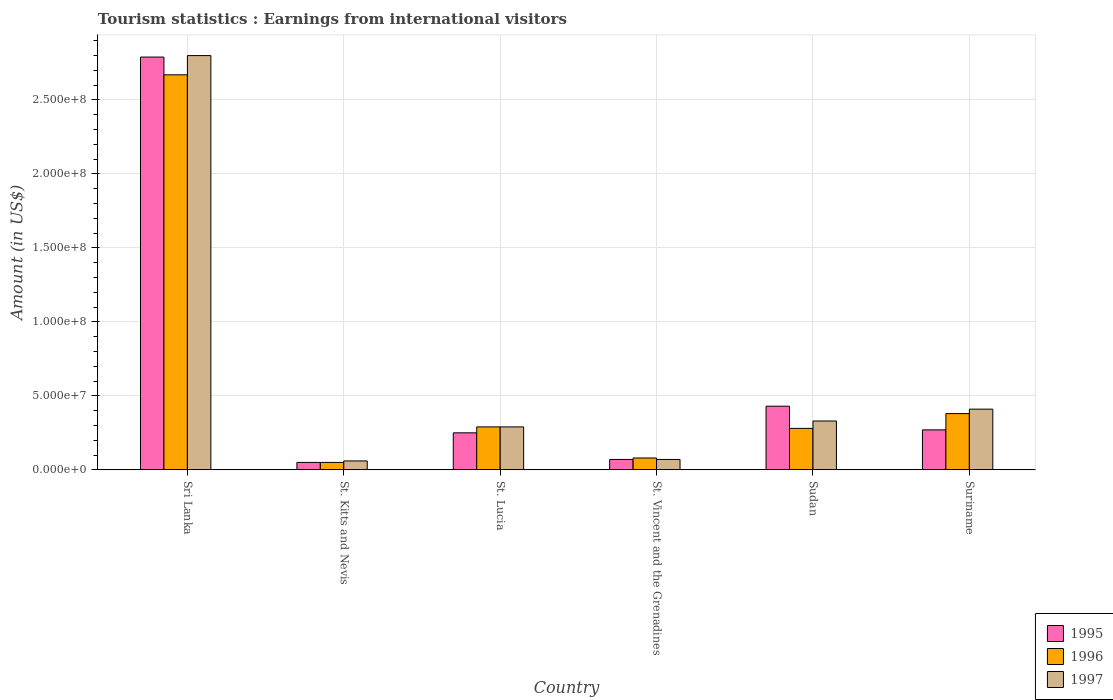How many groups of bars are there?
Make the answer very short. 6. How many bars are there on the 5th tick from the left?
Your answer should be compact. 3. How many bars are there on the 6th tick from the right?
Offer a terse response. 3. What is the label of the 3rd group of bars from the left?
Ensure brevity in your answer.  St. Lucia. What is the earnings from international visitors in 1997 in Sri Lanka?
Your answer should be very brief. 2.80e+08. Across all countries, what is the maximum earnings from international visitors in 1996?
Your response must be concise. 2.67e+08. Across all countries, what is the minimum earnings from international visitors in 1997?
Provide a succinct answer. 6.00e+06. In which country was the earnings from international visitors in 1997 maximum?
Offer a very short reply. Sri Lanka. In which country was the earnings from international visitors in 1996 minimum?
Make the answer very short. St. Kitts and Nevis. What is the total earnings from international visitors in 1996 in the graph?
Your answer should be very brief. 3.75e+08. What is the difference between the earnings from international visitors in 1996 in Sri Lanka and that in St. Kitts and Nevis?
Provide a succinct answer. 2.62e+08. What is the difference between the earnings from international visitors in 1996 in Sudan and the earnings from international visitors in 1995 in St. Kitts and Nevis?
Your answer should be compact. 2.30e+07. What is the average earnings from international visitors in 1995 per country?
Offer a very short reply. 6.43e+07. What is the ratio of the earnings from international visitors in 1997 in Sri Lanka to that in Sudan?
Your answer should be very brief. 8.48. Is the earnings from international visitors in 1995 in Sri Lanka less than that in St. Kitts and Nevis?
Offer a terse response. No. What is the difference between the highest and the second highest earnings from international visitors in 1997?
Make the answer very short. 2.47e+08. What is the difference between the highest and the lowest earnings from international visitors in 1997?
Ensure brevity in your answer.  2.74e+08. In how many countries, is the earnings from international visitors in 1997 greater than the average earnings from international visitors in 1997 taken over all countries?
Provide a short and direct response. 1. Is the sum of the earnings from international visitors in 1996 in St. Vincent and the Grenadines and Suriname greater than the maximum earnings from international visitors in 1995 across all countries?
Your answer should be compact. No. What does the 3rd bar from the left in St. Lucia represents?
Offer a terse response. 1997. Is it the case that in every country, the sum of the earnings from international visitors in 1997 and earnings from international visitors in 1996 is greater than the earnings from international visitors in 1995?
Your response must be concise. Yes. How many countries are there in the graph?
Make the answer very short. 6. Are the values on the major ticks of Y-axis written in scientific E-notation?
Keep it short and to the point. Yes. Does the graph contain grids?
Give a very brief answer. Yes. Where does the legend appear in the graph?
Provide a succinct answer. Bottom right. How are the legend labels stacked?
Your answer should be very brief. Vertical. What is the title of the graph?
Provide a short and direct response. Tourism statistics : Earnings from international visitors. Does "1963" appear as one of the legend labels in the graph?
Provide a succinct answer. No. What is the Amount (in US$) of 1995 in Sri Lanka?
Offer a very short reply. 2.79e+08. What is the Amount (in US$) in 1996 in Sri Lanka?
Ensure brevity in your answer.  2.67e+08. What is the Amount (in US$) of 1997 in Sri Lanka?
Your answer should be very brief. 2.80e+08. What is the Amount (in US$) in 1995 in St. Kitts and Nevis?
Keep it short and to the point. 5.00e+06. What is the Amount (in US$) in 1996 in St. Kitts and Nevis?
Ensure brevity in your answer.  5.00e+06. What is the Amount (in US$) in 1995 in St. Lucia?
Your answer should be very brief. 2.50e+07. What is the Amount (in US$) of 1996 in St. Lucia?
Give a very brief answer. 2.90e+07. What is the Amount (in US$) in 1997 in St. Lucia?
Offer a very short reply. 2.90e+07. What is the Amount (in US$) in 1995 in Sudan?
Your answer should be compact. 4.30e+07. What is the Amount (in US$) in 1996 in Sudan?
Your answer should be very brief. 2.80e+07. What is the Amount (in US$) of 1997 in Sudan?
Make the answer very short. 3.30e+07. What is the Amount (in US$) in 1995 in Suriname?
Ensure brevity in your answer.  2.70e+07. What is the Amount (in US$) in 1996 in Suriname?
Provide a short and direct response. 3.80e+07. What is the Amount (in US$) of 1997 in Suriname?
Your response must be concise. 4.10e+07. Across all countries, what is the maximum Amount (in US$) in 1995?
Give a very brief answer. 2.79e+08. Across all countries, what is the maximum Amount (in US$) in 1996?
Keep it short and to the point. 2.67e+08. Across all countries, what is the maximum Amount (in US$) in 1997?
Make the answer very short. 2.80e+08. Across all countries, what is the minimum Amount (in US$) of 1996?
Your answer should be compact. 5.00e+06. Across all countries, what is the minimum Amount (in US$) in 1997?
Your answer should be compact. 6.00e+06. What is the total Amount (in US$) in 1995 in the graph?
Ensure brevity in your answer.  3.86e+08. What is the total Amount (in US$) in 1996 in the graph?
Your response must be concise. 3.75e+08. What is the total Amount (in US$) of 1997 in the graph?
Keep it short and to the point. 3.96e+08. What is the difference between the Amount (in US$) in 1995 in Sri Lanka and that in St. Kitts and Nevis?
Keep it short and to the point. 2.74e+08. What is the difference between the Amount (in US$) of 1996 in Sri Lanka and that in St. Kitts and Nevis?
Offer a terse response. 2.62e+08. What is the difference between the Amount (in US$) in 1997 in Sri Lanka and that in St. Kitts and Nevis?
Your answer should be very brief. 2.74e+08. What is the difference between the Amount (in US$) of 1995 in Sri Lanka and that in St. Lucia?
Provide a succinct answer. 2.54e+08. What is the difference between the Amount (in US$) of 1996 in Sri Lanka and that in St. Lucia?
Ensure brevity in your answer.  2.38e+08. What is the difference between the Amount (in US$) of 1997 in Sri Lanka and that in St. Lucia?
Provide a short and direct response. 2.51e+08. What is the difference between the Amount (in US$) of 1995 in Sri Lanka and that in St. Vincent and the Grenadines?
Your answer should be compact. 2.72e+08. What is the difference between the Amount (in US$) of 1996 in Sri Lanka and that in St. Vincent and the Grenadines?
Your answer should be very brief. 2.59e+08. What is the difference between the Amount (in US$) in 1997 in Sri Lanka and that in St. Vincent and the Grenadines?
Make the answer very short. 2.73e+08. What is the difference between the Amount (in US$) in 1995 in Sri Lanka and that in Sudan?
Provide a short and direct response. 2.36e+08. What is the difference between the Amount (in US$) in 1996 in Sri Lanka and that in Sudan?
Your response must be concise. 2.39e+08. What is the difference between the Amount (in US$) of 1997 in Sri Lanka and that in Sudan?
Your answer should be very brief. 2.47e+08. What is the difference between the Amount (in US$) in 1995 in Sri Lanka and that in Suriname?
Your answer should be very brief. 2.52e+08. What is the difference between the Amount (in US$) in 1996 in Sri Lanka and that in Suriname?
Your response must be concise. 2.29e+08. What is the difference between the Amount (in US$) in 1997 in Sri Lanka and that in Suriname?
Your answer should be compact. 2.39e+08. What is the difference between the Amount (in US$) of 1995 in St. Kitts and Nevis and that in St. Lucia?
Ensure brevity in your answer.  -2.00e+07. What is the difference between the Amount (in US$) of 1996 in St. Kitts and Nevis and that in St. Lucia?
Your answer should be very brief. -2.40e+07. What is the difference between the Amount (in US$) in 1997 in St. Kitts and Nevis and that in St. Lucia?
Offer a very short reply. -2.30e+07. What is the difference between the Amount (in US$) in 1996 in St. Kitts and Nevis and that in St. Vincent and the Grenadines?
Ensure brevity in your answer.  -3.00e+06. What is the difference between the Amount (in US$) of 1995 in St. Kitts and Nevis and that in Sudan?
Keep it short and to the point. -3.80e+07. What is the difference between the Amount (in US$) in 1996 in St. Kitts and Nevis and that in Sudan?
Your answer should be very brief. -2.30e+07. What is the difference between the Amount (in US$) in 1997 in St. Kitts and Nevis and that in Sudan?
Your answer should be very brief. -2.70e+07. What is the difference between the Amount (in US$) of 1995 in St. Kitts and Nevis and that in Suriname?
Ensure brevity in your answer.  -2.20e+07. What is the difference between the Amount (in US$) in 1996 in St. Kitts and Nevis and that in Suriname?
Provide a short and direct response. -3.30e+07. What is the difference between the Amount (in US$) in 1997 in St. Kitts and Nevis and that in Suriname?
Make the answer very short. -3.50e+07. What is the difference between the Amount (in US$) in 1995 in St. Lucia and that in St. Vincent and the Grenadines?
Keep it short and to the point. 1.80e+07. What is the difference between the Amount (in US$) of 1996 in St. Lucia and that in St. Vincent and the Grenadines?
Ensure brevity in your answer.  2.10e+07. What is the difference between the Amount (in US$) of 1997 in St. Lucia and that in St. Vincent and the Grenadines?
Keep it short and to the point. 2.20e+07. What is the difference between the Amount (in US$) in 1995 in St. Lucia and that in Sudan?
Offer a terse response. -1.80e+07. What is the difference between the Amount (in US$) in 1996 in St. Lucia and that in Sudan?
Give a very brief answer. 1.00e+06. What is the difference between the Amount (in US$) in 1996 in St. Lucia and that in Suriname?
Your answer should be compact. -9.00e+06. What is the difference between the Amount (in US$) in 1997 in St. Lucia and that in Suriname?
Your answer should be compact. -1.20e+07. What is the difference between the Amount (in US$) in 1995 in St. Vincent and the Grenadines and that in Sudan?
Offer a very short reply. -3.60e+07. What is the difference between the Amount (in US$) of 1996 in St. Vincent and the Grenadines and that in Sudan?
Your response must be concise. -2.00e+07. What is the difference between the Amount (in US$) in 1997 in St. Vincent and the Grenadines and that in Sudan?
Provide a succinct answer. -2.60e+07. What is the difference between the Amount (in US$) in 1995 in St. Vincent and the Grenadines and that in Suriname?
Offer a terse response. -2.00e+07. What is the difference between the Amount (in US$) in 1996 in St. Vincent and the Grenadines and that in Suriname?
Ensure brevity in your answer.  -3.00e+07. What is the difference between the Amount (in US$) in 1997 in St. Vincent and the Grenadines and that in Suriname?
Offer a terse response. -3.40e+07. What is the difference between the Amount (in US$) in 1995 in Sudan and that in Suriname?
Keep it short and to the point. 1.60e+07. What is the difference between the Amount (in US$) in 1996 in Sudan and that in Suriname?
Your answer should be compact. -1.00e+07. What is the difference between the Amount (in US$) of 1997 in Sudan and that in Suriname?
Your answer should be very brief. -8.00e+06. What is the difference between the Amount (in US$) in 1995 in Sri Lanka and the Amount (in US$) in 1996 in St. Kitts and Nevis?
Make the answer very short. 2.74e+08. What is the difference between the Amount (in US$) in 1995 in Sri Lanka and the Amount (in US$) in 1997 in St. Kitts and Nevis?
Your response must be concise. 2.73e+08. What is the difference between the Amount (in US$) in 1996 in Sri Lanka and the Amount (in US$) in 1997 in St. Kitts and Nevis?
Ensure brevity in your answer.  2.61e+08. What is the difference between the Amount (in US$) of 1995 in Sri Lanka and the Amount (in US$) of 1996 in St. Lucia?
Ensure brevity in your answer.  2.50e+08. What is the difference between the Amount (in US$) of 1995 in Sri Lanka and the Amount (in US$) of 1997 in St. Lucia?
Provide a short and direct response. 2.50e+08. What is the difference between the Amount (in US$) in 1996 in Sri Lanka and the Amount (in US$) in 1997 in St. Lucia?
Offer a very short reply. 2.38e+08. What is the difference between the Amount (in US$) in 1995 in Sri Lanka and the Amount (in US$) in 1996 in St. Vincent and the Grenadines?
Ensure brevity in your answer.  2.71e+08. What is the difference between the Amount (in US$) of 1995 in Sri Lanka and the Amount (in US$) of 1997 in St. Vincent and the Grenadines?
Your answer should be very brief. 2.72e+08. What is the difference between the Amount (in US$) in 1996 in Sri Lanka and the Amount (in US$) in 1997 in St. Vincent and the Grenadines?
Offer a very short reply. 2.60e+08. What is the difference between the Amount (in US$) in 1995 in Sri Lanka and the Amount (in US$) in 1996 in Sudan?
Offer a very short reply. 2.51e+08. What is the difference between the Amount (in US$) of 1995 in Sri Lanka and the Amount (in US$) of 1997 in Sudan?
Provide a succinct answer. 2.46e+08. What is the difference between the Amount (in US$) in 1996 in Sri Lanka and the Amount (in US$) in 1997 in Sudan?
Give a very brief answer. 2.34e+08. What is the difference between the Amount (in US$) in 1995 in Sri Lanka and the Amount (in US$) in 1996 in Suriname?
Your answer should be very brief. 2.41e+08. What is the difference between the Amount (in US$) of 1995 in Sri Lanka and the Amount (in US$) of 1997 in Suriname?
Provide a short and direct response. 2.38e+08. What is the difference between the Amount (in US$) of 1996 in Sri Lanka and the Amount (in US$) of 1997 in Suriname?
Give a very brief answer. 2.26e+08. What is the difference between the Amount (in US$) of 1995 in St. Kitts and Nevis and the Amount (in US$) of 1996 in St. Lucia?
Provide a succinct answer. -2.40e+07. What is the difference between the Amount (in US$) in 1995 in St. Kitts and Nevis and the Amount (in US$) in 1997 in St. Lucia?
Make the answer very short. -2.40e+07. What is the difference between the Amount (in US$) of 1996 in St. Kitts and Nevis and the Amount (in US$) of 1997 in St. Lucia?
Offer a terse response. -2.40e+07. What is the difference between the Amount (in US$) of 1995 in St. Kitts and Nevis and the Amount (in US$) of 1996 in St. Vincent and the Grenadines?
Provide a short and direct response. -3.00e+06. What is the difference between the Amount (in US$) in 1995 in St. Kitts and Nevis and the Amount (in US$) in 1997 in St. Vincent and the Grenadines?
Keep it short and to the point. -2.00e+06. What is the difference between the Amount (in US$) in 1995 in St. Kitts and Nevis and the Amount (in US$) in 1996 in Sudan?
Give a very brief answer. -2.30e+07. What is the difference between the Amount (in US$) of 1995 in St. Kitts and Nevis and the Amount (in US$) of 1997 in Sudan?
Your answer should be compact. -2.80e+07. What is the difference between the Amount (in US$) in 1996 in St. Kitts and Nevis and the Amount (in US$) in 1997 in Sudan?
Provide a succinct answer. -2.80e+07. What is the difference between the Amount (in US$) in 1995 in St. Kitts and Nevis and the Amount (in US$) in 1996 in Suriname?
Give a very brief answer. -3.30e+07. What is the difference between the Amount (in US$) in 1995 in St. Kitts and Nevis and the Amount (in US$) in 1997 in Suriname?
Your response must be concise. -3.60e+07. What is the difference between the Amount (in US$) of 1996 in St. Kitts and Nevis and the Amount (in US$) of 1997 in Suriname?
Your answer should be compact. -3.60e+07. What is the difference between the Amount (in US$) of 1995 in St. Lucia and the Amount (in US$) of 1996 in St. Vincent and the Grenadines?
Provide a succinct answer. 1.70e+07. What is the difference between the Amount (in US$) in 1995 in St. Lucia and the Amount (in US$) in 1997 in St. Vincent and the Grenadines?
Provide a short and direct response. 1.80e+07. What is the difference between the Amount (in US$) of 1996 in St. Lucia and the Amount (in US$) of 1997 in St. Vincent and the Grenadines?
Offer a terse response. 2.20e+07. What is the difference between the Amount (in US$) of 1995 in St. Lucia and the Amount (in US$) of 1996 in Sudan?
Give a very brief answer. -3.00e+06. What is the difference between the Amount (in US$) in 1995 in St. Lucia and the Amount (in US$) in 1997 in Sudan?
Provide a succinct answer. -8.00e+06. What is the difference between the Amount (in US$) of 1995 in St. Lucia and the Amount (in US$) of 1996 in Suriname?
Provide a succinct answer. -1.30e+07. What is the difference between the Amount (in US$) in 1995 in St. Lucia and the Amount (in US$) in 1997 in Suriname?
Keep it short and to the point. -1.60e+07. What is the difference between the Amount (in US$) in 1996 in St. Lucia and the Amount (in US$) in 1997 in Suriname?
Your response must be concise. -1.20e+07. What is the difference between the Amount (in US$) of 1995 in St. Vincent and the Grenadines and the Amount (in US$) of 1996 in Sudan?
Give a very brief answer. -2.10e+07. What is the difference between the Amount (in US$) of 1995 in St. Vincent and the Grenadines and the Amount (in US$) of 1997 in Sudan?
Offer a very short reply. -2.60e+07. What is the difference between the Amount (in US$) in 1996 in St. Vincent and the Grenadines and the Amount (in US$) in 1997 in Sudan?
Provide a short and direct response. -2.50e+07. What is the difference between the Amount (in US$) of 1995 in St. Vincent and the Grenadines and the Amount (in US$) of 1996 in Suriname?
Make the answer very short. -3.10e+07. What is the difference between the Amount (in US$) of 1995 in St. Vincent and the Grenadines and the Amount (in US$) of 1997 in Suriname?
Give a very brief answer. -3.40e+07. What is the difference between the Amount (in US$) of 1996 in St. Vincent and the Grenadines and the Amount (in US$) of 1997 in Suriname?
Offer a terse response. -3.30e+07. What is the difference between the Amount (in US$) of 1996 in Sudan and the Amount (in US$) of 1997 in Suriname?
Your response must be concise. -1.30e+07. What is the average Amount (in US$) in 1995 per country?
Provide a succinct answer. 6.43e+07. What is the average Amount (in US$) in 1996 per country?
Provide a succinct answer. 6.25e+07. What is the average Amount (in US$) of 1997 per country?
Ensure brevity in your answer.  6.60e+07. What is the difference between the Amount (in US$) of 1995 and Amount (in US$) of 1996 in Sri Lanka?
Make the answer very short. 1.20e+07. What is the difference between the Amount (in US$) of 1995 and Amount (in US$) of 1997 in Sri Lanka?
Your response must be concise. -1.00e+06. What is the difference between the Amount (in US$) of 1996 and Amount (in US$) of 1997 in Sri Lanka?
Your response must be concise. -1.30e+07. What is the difference between the Amount (in US$) in 1995 and Amount (in US$) in 1997 in St. Kitts and Nevis?
Your response must be concise. -1.00e+06. What is the difference between the Amount (in US$) in 1995 and Amount (in US$) in 1996 in St. Lucia?
Provide a short and direct response. -4.00e+06. What is the difference between the Amount (in US$) in 1996 and Amount (in US$) in 1997 in St. Lucia?
Your answer should be compact. 0. What is the difference between the Amount (in US$) of 1995 and Amount (in US$) of 1996 in St. Vincent and the Grenadines?
Offer a very short reply. -1.00e+06. What is the difference between the Amount (in US$) of 1995 and Amount (in US$) of 1996 in Sudan?
Your response must be concise. 1.50e+07. What is the difference between the Amount (in US$) of 1995 and Amount (in US$) of 1997 in Sudan?
Make the answer very short. 1.00e+07. What is the difference between the Amount (in US$) in 1996 and Amount (in US$) in 1997 in Sudan?
Ensure brevity in your answer.  -5.00e+06. What is the difference between the Amount (in US$) of 1995 and Amount (in US$) of 1996 in Suriname?
Offer a terse response. -1.10e+07. What is the difference between the Amount (in US$) of 1995 and Amount (in US$) of 1997 in Suriname?
Ensure brevity in your answer.  -1.40e+07. What is the difference between the Amount (in US$) of 1996 and Amount (in US$) of 1997 in Suriname?
Your answer should be compact. -3.00e+06. What is the ratio of the Amount (in US$) in 1995 in Sri Lanka to that in St. Kitts and Nevis?
Offer a terse response. 55.8. What is the ratio of the Amount (in US$) of 1996 in Sri Lanka to that in St. Kitts and Nevis?
Offer a terse response. 53.4. What is the ratio of the Amount (in US$) in 1997 in Sri Lanka to that in St. Kitts and Nevis?
Make the answer very short. 46.67. What is the ratio of the Amount (in US$) in 1995 in Sri Lanka to that in St. Lucia?
Keep it short and to the point. 11.16. What is the ratio of the Amount (in US$) of 1996 in Sri Lanka to that in St. Lucia?
Offer a very short reply. 9.21. What is the ratio of the Amount (in US$) in 1997 in Sri Lanka to that in St. Lucia?
Your response must be concise. 9.66. What is the ratio of the Amount (in US$) of 1995 in Sri Lanka to that in St. Vincent and the Grenadines?
Offer a very short reply. 39.86. What is the ratio of the Amount (in US$) of 1996 in Sri Lanka to that in St. Vincent and the Grenadines?
Provide a succinct answer. 33.38. What is the ratio of the Amount (in US$) in 1995 in Sri Lanka to that in Sudan?
Keep it short and to the point. 6.49. What is the ratio of the Amount (in US$) in 1996 in Sri Lanka to that in Sudan?
Your response must be concise. 9.54. What is the ratio of the Amount (in US$) in 1997 in Sri Lanka to that in Sudan?
Offer a very short reply. 8.48. What is the ratio of the Amount (in US$) in 1995 in Sri Lanka to that in Suriname?
Offer a very short reply. 10.33. What is the ratio of the Amount (in US$) of 1996 in Sri Lanka to that in Suriname?
Your answer should be very brief. 7.03. What is the ratio of the Amount (in US$) in 1997 in Sri Lanka to that in Suriname?
Give a very brief answer. 6.83. What is the ratio of the Amount (in US$) in 1995 in St. Kitts and Nevis to that in St. Lucia?
Make the answer very short. 0.2. What is the ratio of the Amount (in US$) in 1996 in St. Kitts and Nevis to that in St. Lucia?
Ensure brevity in your answer.  0.17. What is the ratio of the Amount (in US$) in 1997 in St. Kitts and Nevis to that in St. Lucia?
Keep it short and to the point. 0.21. What is the ratio of the Amount (in US$) in 1995 in St. Kitts and Nevis to that in Sudan?
Offer a very short reply. 0.12. What is the ratio of the Amount (in US$) of 1996 in St. Kitts and Nevis to that in Sudan?
Ensure brevity in your answer.  0.18. What is the ratio of the Amount (in US$) in 1997 in St. Kitts and Nevis to that in Sudan?
Ensure brevity in your answer.  0.18. What is the ratio of the Amount (in US$) of 1995 in St. Kitts and Nevis to that in Suriname?
Provide a succinct answer. 0.19. What is the ratio of the Amount (in US$) of 1996 in St. Kitts and Nevis to that in Suriname?
Make the answer very short. 0.13. What is the ratio of the Amount (in US$) in 1997 in St. Kitts and Nevis to that in Suriname?
Your response must be concise. 0.15. What is the ratio of the Amount (in US$) of 1995 in St. Lucia to that in St. Vincent and the Grenadines?
Your answer should be very brief. 3.57. What is the ratio of the Amount (in US$) in 1996 in St. Lucia to that in St. Vincent and the Grenadines?
Make the answer very short. 3.62. What is the ratio of the Amount (in US$) in 1997 in St. Lucia to that in St. Vincent and the Grenadines?
Make the answer very short. 4.14. What is the ratio of the Amount (in US$) of 1995 in St. Lucia to that in Sudan?
Your response must be concise. 0.58. What is the ratio of the Amount (in US$) of 1996 in St. Lucia to that in Sudan?
Offer a very short reply. 1.04. What is the ratio of the Amount (in US$) of 1997 in St. Lucia to that in Sudan?
Offer a terse response. 0.88. What is the ratio of the Amount (in US$) in 1995 in St. Lucia to that in Suriname?
Your answer should be very brief. 0.93. What is the ratio of the Amount (in US$) of 1996 in St. Lucia to that in Suriname?
Provide a succinct answer. 0.76. What is the ratio of the Amount (in US$) in 1997 in St. Lucia to that in Suriname?
Keep it short and to the point. 0.71. What is the ratio of the Amount (in US$) in 1995 in St. Vincent and the Grenadines to that in Sudan?
Keep it short and to the point. 0.16. What is the ratio of the Amount (in US$) of 1996 in St. Vincent and the Grenadines to that in Sudan?
Provide a short and direct response. 0.29. What is the ratio of the Amount (in US$) of 1997 in St. Vincent and the Grenadines to that in Sudan?
Your answer should be compact. 0.21. What is the ratio of the Amount (in US$) of 1995 in St. Vincent and the Grenadines to that in Suriname?
Offer a very short reply. 0.26. What is the ratio of the Amount (in US$) of 1996 in St. Vincent and the Grenadines to that in Suriname?
Provide a short and direct response. 0.21. What is the ratio of the Amount (in US$) in 1997 in St. Vincent and the Grenadines to that in Suriname?
Make the answer very short. 0.17. What is the ratio of the Amount (in US$) in 1995 in Sudan to that in Suriname?
Ensure brevity in your answer.  1.59. What is the ratio of the Amount (in US$) in 1996 in Sudan to that in Suriname?
Provide a short and direct response. 0.74. What is the ratio of the Amount (in US$) of 1997 in Sudan to that in Suriname?
Make the answer very short. 0.8. What is the difference between the highest and the second highest Amount (in US$) in 1995?
Offer a very short reply. 2.36e+08. What is the difference between the highest and the second highest Amount (in US$) of 1996?
Keep it short and to the point. 2.29e+08. What is the difference between the highest and the second highest Amount (in US$) in 1997?
Ensure brevity in your answer.  2.39e+08. What is the difference between the highest and the lowest Amount (in US$) of 1995?
Offer a terse response. 2.74e+08. What is the difference between the highest and the lowest Amount (in US$) in 1996?
Ensure brevity in your answer.  2.62e+08. What is the difference between the highest and the lowest Amount (in US$) of 1997?
Offer a terse response. 2.74e+08. 